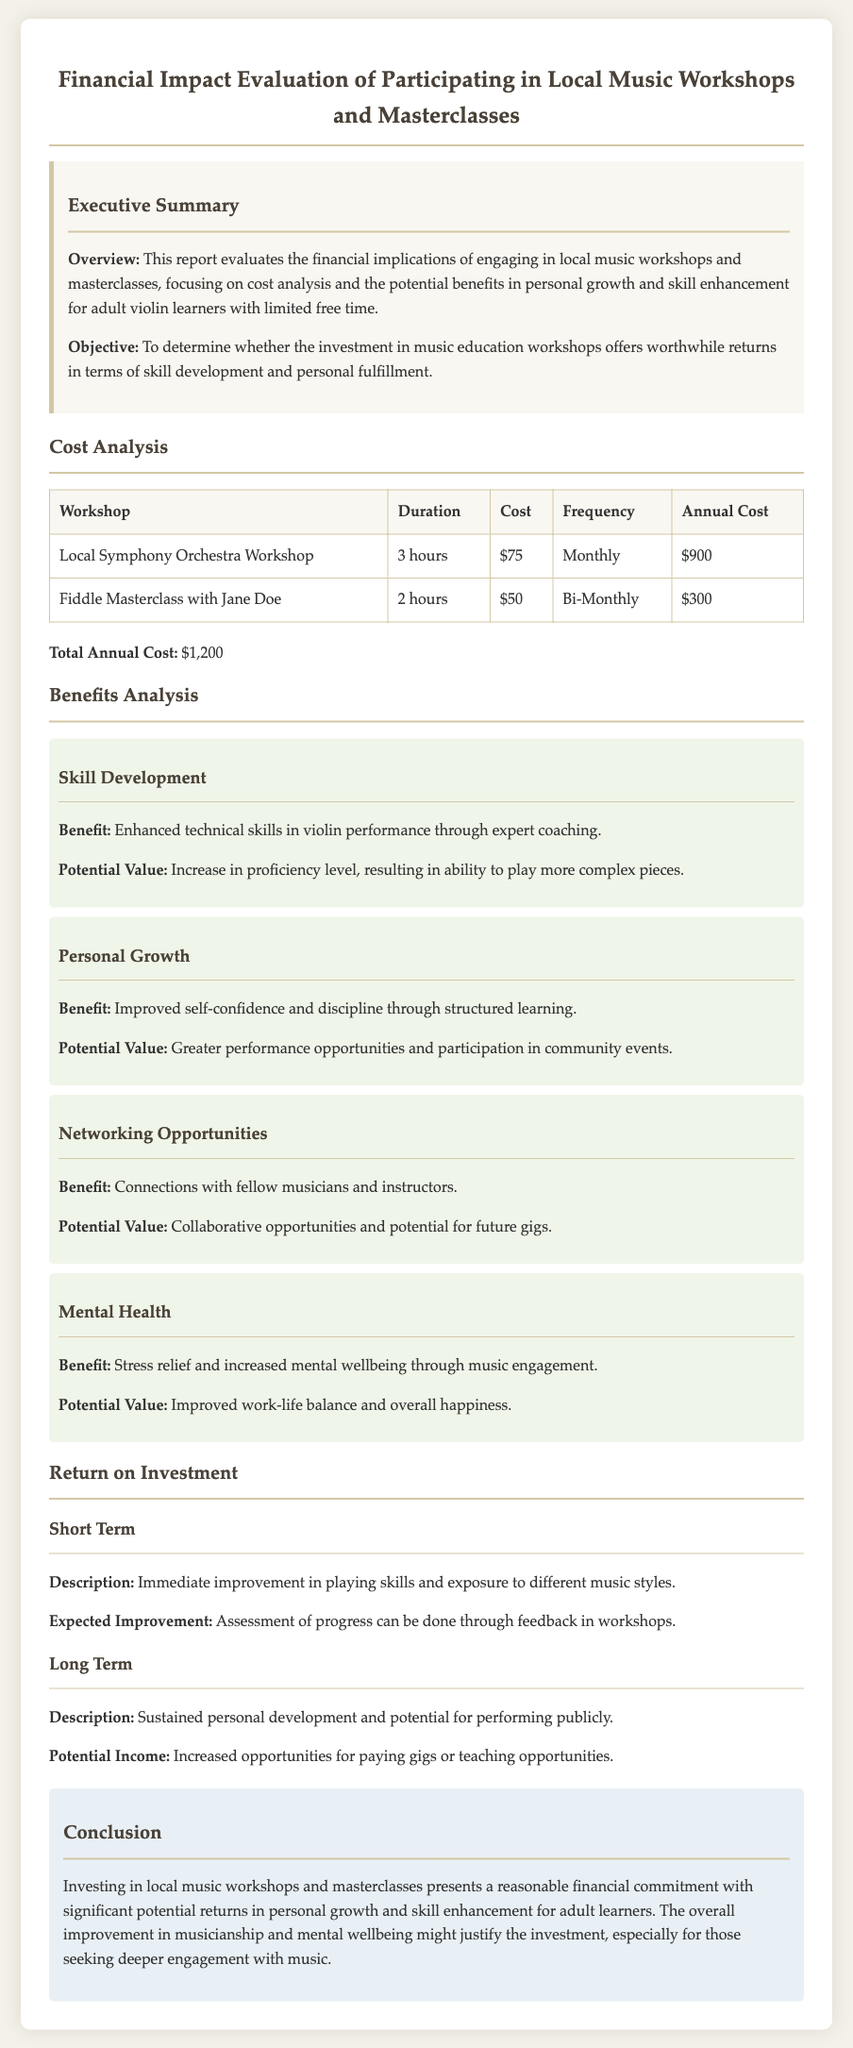What is the total annual cost of the workshops? The total annual cost is mentioned as the sum of all individual workshop costs, which is $900 + $300.
Answer: $1,200 What is the duration of the Local Symphony Orchestra Workshop? The duration is provided in the cost analysis section, specifying how long each workshop lasts.
Answer: 3 hours How often does the Fiddle Masterclass occur? The frequency of the Fiddle Masterclass is stated in the cost analysis table.
Answer: Bi-Monthly What is one benefit of skill development mentioned in the report? The report lists specific benefits of participating in workshops with a focus on skill enhancement for violin learners.
Answer: Enhanced technical skills What is the potential value of improved self-confidence? The report outlines potential benefits and values associated with personal growth, specifying the positive outcomes of structured learning.
Answer: Greater performance opportunities What is the expected improvement from workshops in the short term? The report describes expected improvements that can be evaluated immediately after participation in workshops.
Answer: Immediate improvement in playing skills What is the potential income discussed in the long term? Details about long-term benefits include the financial opportunities gained from participation in music events.
Answer: Increased opportunities for paying gigs What is the purpose of this financial report? The objective is clearly stated at the beginning, outlining the report's intent in relation to music education workshops.
Answer: To determine worthwhile returns in skill development 